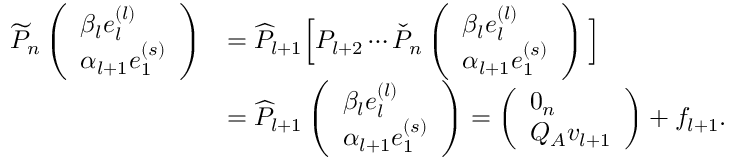<formula> <loc_0><loc_0><loc_500><loc_500>\begin{array} { r l } { \widetilde { P } _ { n } \left ( \begin{array} { l } { \beta _ { l } e _ { l } ^ { ( l ) } } \\ { \alpha _ { l + 1 } e _ { 1 } ^ { ( s ) } } \end{array} \right ) } & { = \widehat { P } _ { l + 1 } \left [ P _ { l + 2 } \cdots \check { P } _ { n } \left ( \begin{array} { l } { \beta _ { l } e _ { l } ^ { ( l ) } } \\ { \alpha _ { l + 1 } e _ { 1 } ^ { ( s ) } } \end{array} \right ) \right ] } \\ & { = \widehat { P } _ { l + 1 } \left ( \begin{array} { l } { \beta _ { l } e _ { l } ^ { ( l ) } } \\ { \alpha _ { l + 1 } e _ { 1 } ^ { ( s ) } } \end{array} \right ) = \left ( \begin{array} { l } { 0 _ { n } } \\ { Q _ { A } v _ { l + 1 } } \end{array} \right ) + f _ { l + 1 } . } \end{array}</formula> 